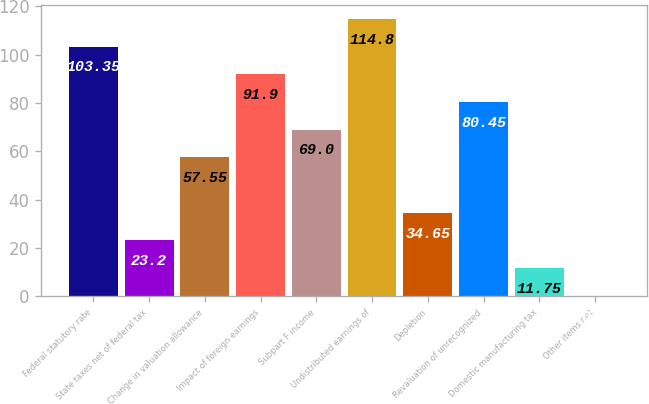<chart> <loc_0><loc_0><loc_500><loc_500><bar_chart><fcel>Federal statutory rate<fcel>State taxes net of federal tax<fcel>Change in valuation allowance<fcel>Impact of foreign earnings<fcel>Subpart F income<fcel>Undistributed earnings of<fcel>Depletion<fcel>Revaluation of unrecognized<fcel>Domestic manufacturing tax<fcel>Other items net<nl><fcel>103.35<fcel>23.2<fcel>57.55<fcel>91.9<fcel>69<fcel>114.8<fcel>34.65<fcel>80.45<fcel>11.75<fcel>0.3<nl></chart> 